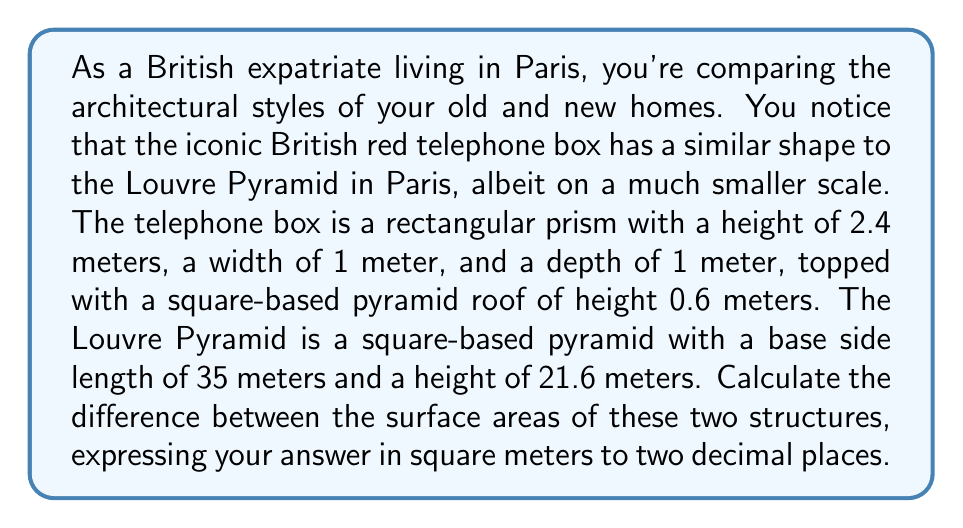Can you solve this math problem? Let's break this down step-by-step:

1) For the British telephone box:
   a) Surface area of the rectangular prism:
      $$A_{prism} = 2(lw + lh + wh)$$
      $$A_{prism} = 2(1 \cdot 1 + 1 \cdot 2.4 + 1 \cdot 2.4) = 10.8 \text{ m}^2$$
   
   b) Surface area of the pyramid roof:
      Base edge length: $a = 1 \text{ m}$
      Height: $h = 0.6 \text{ m}$
      Slant height: $s = \sqrt{(0.5)^2 + 0.6^2} = 0.781 \text{ m}$
      $$A_{roof} = a^2 + 4 \cdot \frac{1}{2}as = 1 + 2 \cdot 0.781 = 2.562 \text{ m}^2$$
   
   c) Total surface area of telephone box:
      $$A_{box} = 10.8 + 2.562 = 13.362 \text{ m}^2$$

2) For the Louvre Pyramid:
   Base edge length: $a = 35 \text{ m}$
   Height: $h = 21.6 \text{ m}$
   Slant height: $s = \sqrt{(17.5)^2 + 21.6^2} = 27.778 \text{ m}$
   
   Surface area of a square-based pyramid:
   $$A_{pyramid} = a^2 + 4 \cdot \frac{1}{2}as$$
   $$A_{pyramid} = 35^2 + 2 \cdot 35 \cdot 27.778 = 3,168.46 \text{ m}^2$$

3) Difference in surface areas:
   $$3,168.46 - 13.362 = 3,155.098 \text{ m}^2$$

Rounded to two decimal places: 3,155.10 m²
Answer: 3,155.10 m² 